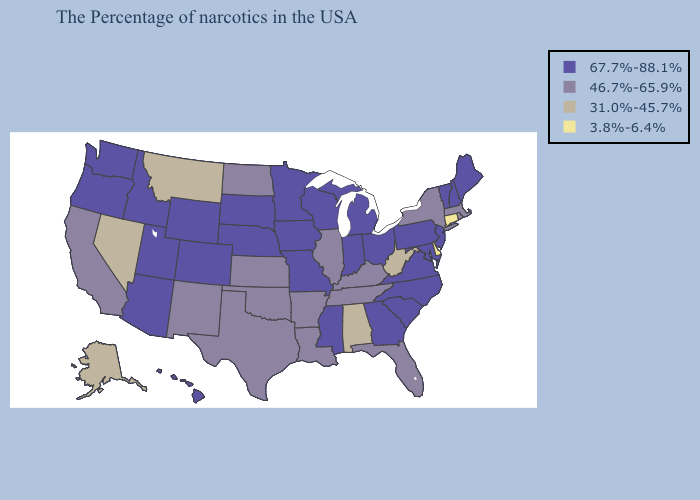What is the lowest value in the MidWest?
Write a very short answer. 46.7%-65.9%. Among the states that border Illinois , does Kentucky have the highest value?
Be succinct. No. Among the states that border Colorado , which have the highest value?
Concise answer only. Nebraska, Wyoming, Utah, Arizona. What is the value of Oregon?
Short answer required. 67.7%-88.1%. Among the states that border Rhode Island , does Connecticut have the lowest value?
Keep it brief. Yes. Does Mississippi have the lowest value in the USA?
Be succinct. No. Among the states that border Connecticut , which have the highest value?
Answer briefly. Massachusetts, Rhode Island, New York. Does Minnesota have the same value as Wyoming?
Give a very brief answer. Yes. Which states hav the highest value in the Northeast?
Give a very brief answer. Maine, New Hampshire, Vermont, New Jersey, Pennsylvania. Does the first symbol in the legend represent the smallest category?
Give a very brief answer. No. Name the states that have a value in the range 31.0%-45.7%?
Answer briefly. West Virginia, Alabama, Montana, Nevada, Alaska. What is the highest value in the Northeast ?
Short answer required. 67.7%-88.1%. Does Rhode Island have the highest value in the Northeast?
Concise answer only. No. Which states hav the highest value in the South?
Give a very brief answer. Maryland, Virginia, North Carolina, South Carolina, Georgia, Mississippi. Does Idaho have a higher value than Alabama?
Keep it brief. Yes. 